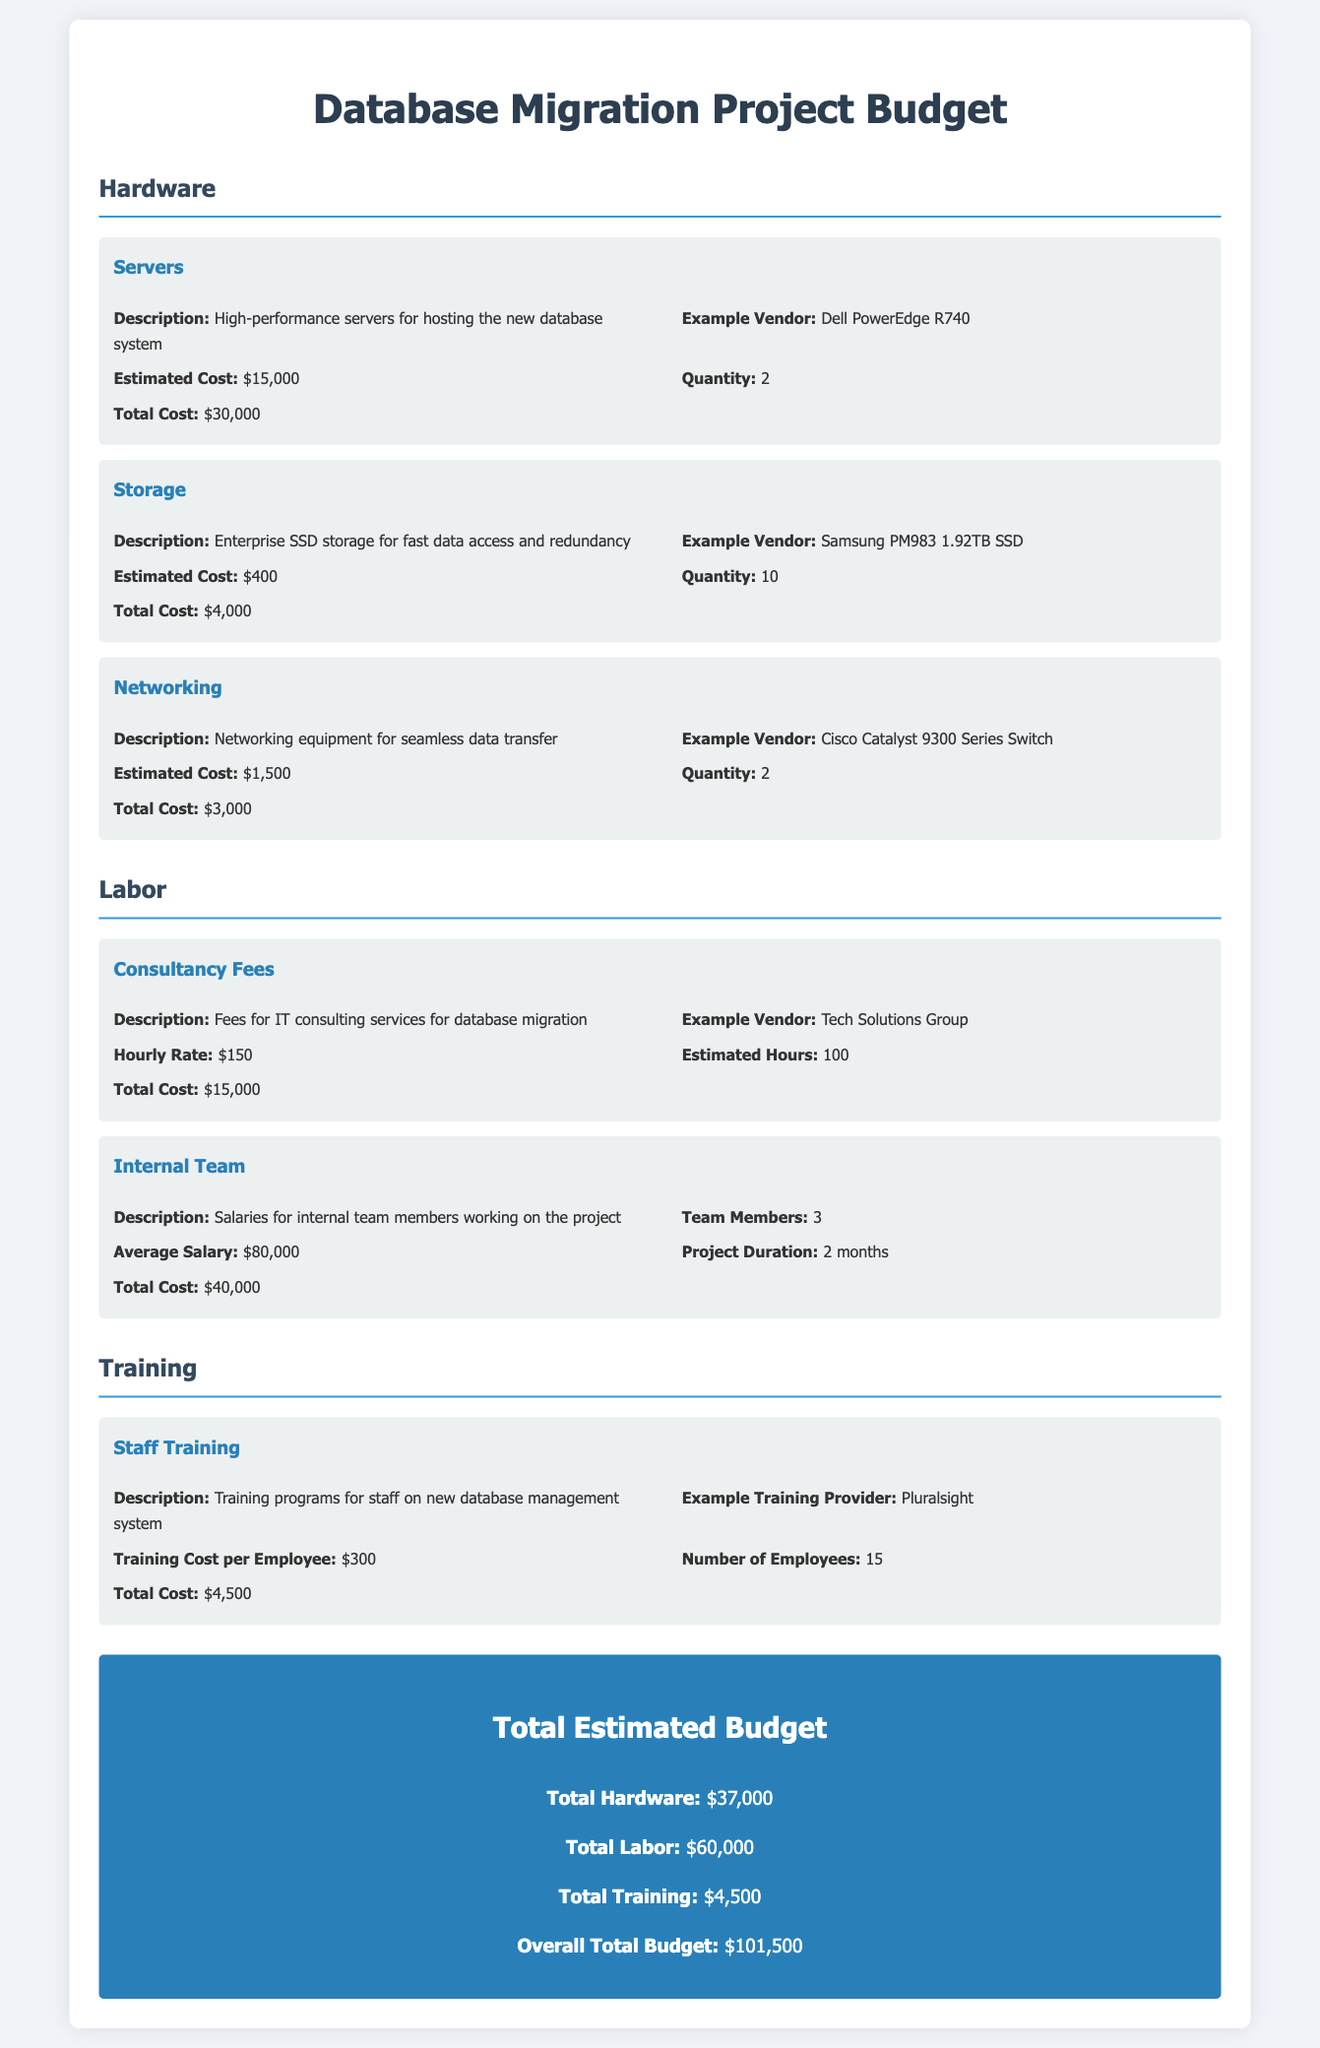What is the total cost for servers? The total cost for servers is $30,000, as indicated in the hardware section of the budget.
Answer: $30,000 How many employees will be trained? The document states that 15 employees will be trained according to the training section.
Answer: 15 What is the estimated cost for storage? The estimated cost for storage, as outlined in the hardware section, is $400.
Answer: $400 What are the total labor costs? The total labor costs are $60,000, which is calculated from consultancy fees and internal team salaries.
Answer: $60,000 What is the hourly rate for consultancy fees? The hourly rate for consultancy fees is $150, as mentioned in the labor section of the document.
Answer: $150 What equipment is included in the networking budget? The networking budget includes Cisco Catalyst 9300 Series Switch as the example vendor.
Answer: Cisco Catalyst 9300 Series Switch What is the average salary for internal team members? The average salary for internal team members is $80,000, as specified in the labor section.
Answer: $80,000 What is the total estimated budget for the project? The overall total budget for the project is $101,500, which summarizes all costs presented in the document.
Answer: $101,500 Which provider is mentioned for staff training? The training provider mentioned in the budget is Pluralsight.
Answer: Pluralsight 